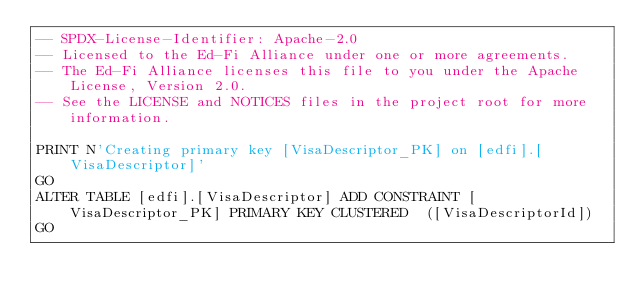<code> <loc_0><loc_0><loc_500><loc_500><_SQL_>-- SPDX-License-Identifier: Apache-2.0
-- Licensed to the Ed-Fi Alliance under one or more agreements.
-- The Ed-Fi Alliance licenses this file to you under the Apache License, Version 2.0.
-- See the LICENSE and NOTICES files in the project root for more information.

PRINT N'Creating primary key [VisaDescriptor_PK] on [edfi].[VisaDescriptor]'
GO
ALTER TABLE [edfi].[VisaDescriptor] ADD CONSTRAINT [VisaDescriptor_PK] PRIMARY KEY CLUSTERED  ([VisaDescriptorId])
GO
</code> 